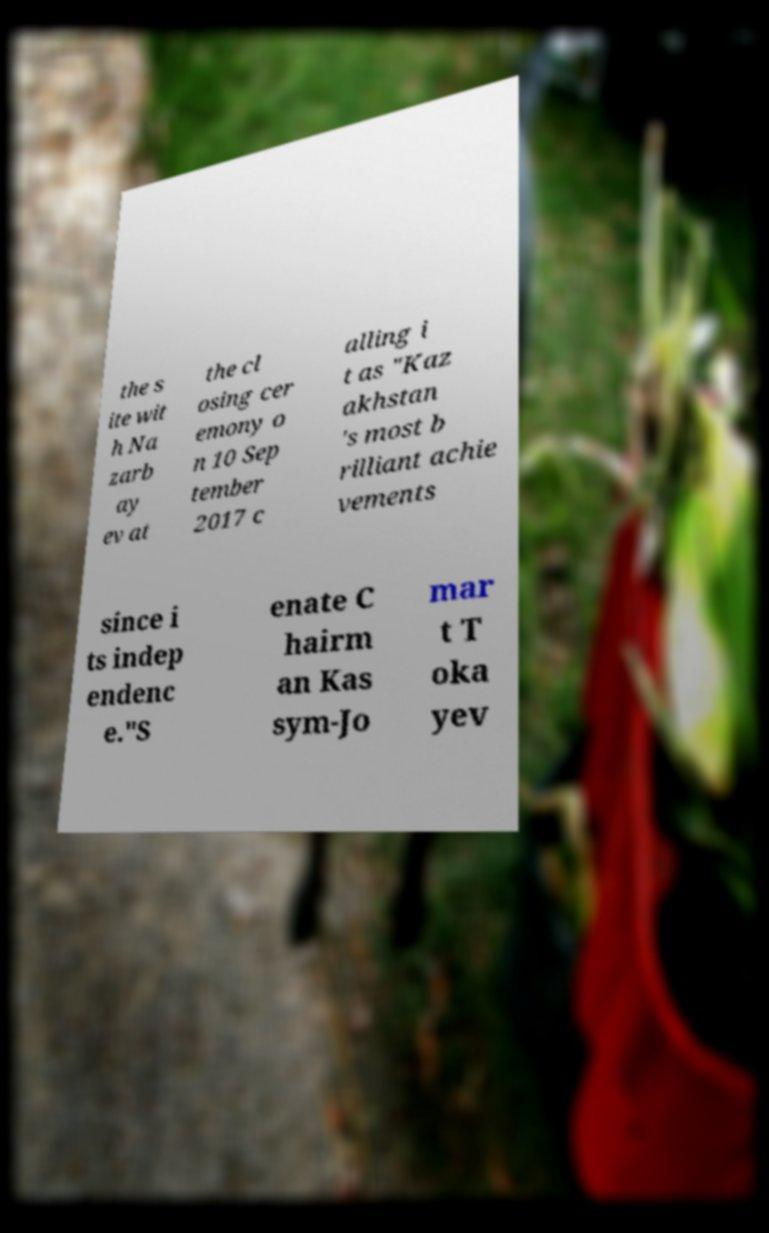Could you assist in decoding the text presented in this image and type it out clearly? the s ite wit h Na zarb ay ev at the cl osing cer emony o n 10 Sep tember 2017 c alling i t as "Kaz akhstan 's most b rilliant achie vements since i ts indep endenc e."S enate C hairm an Kas sym-Jo mar t T oka yev 